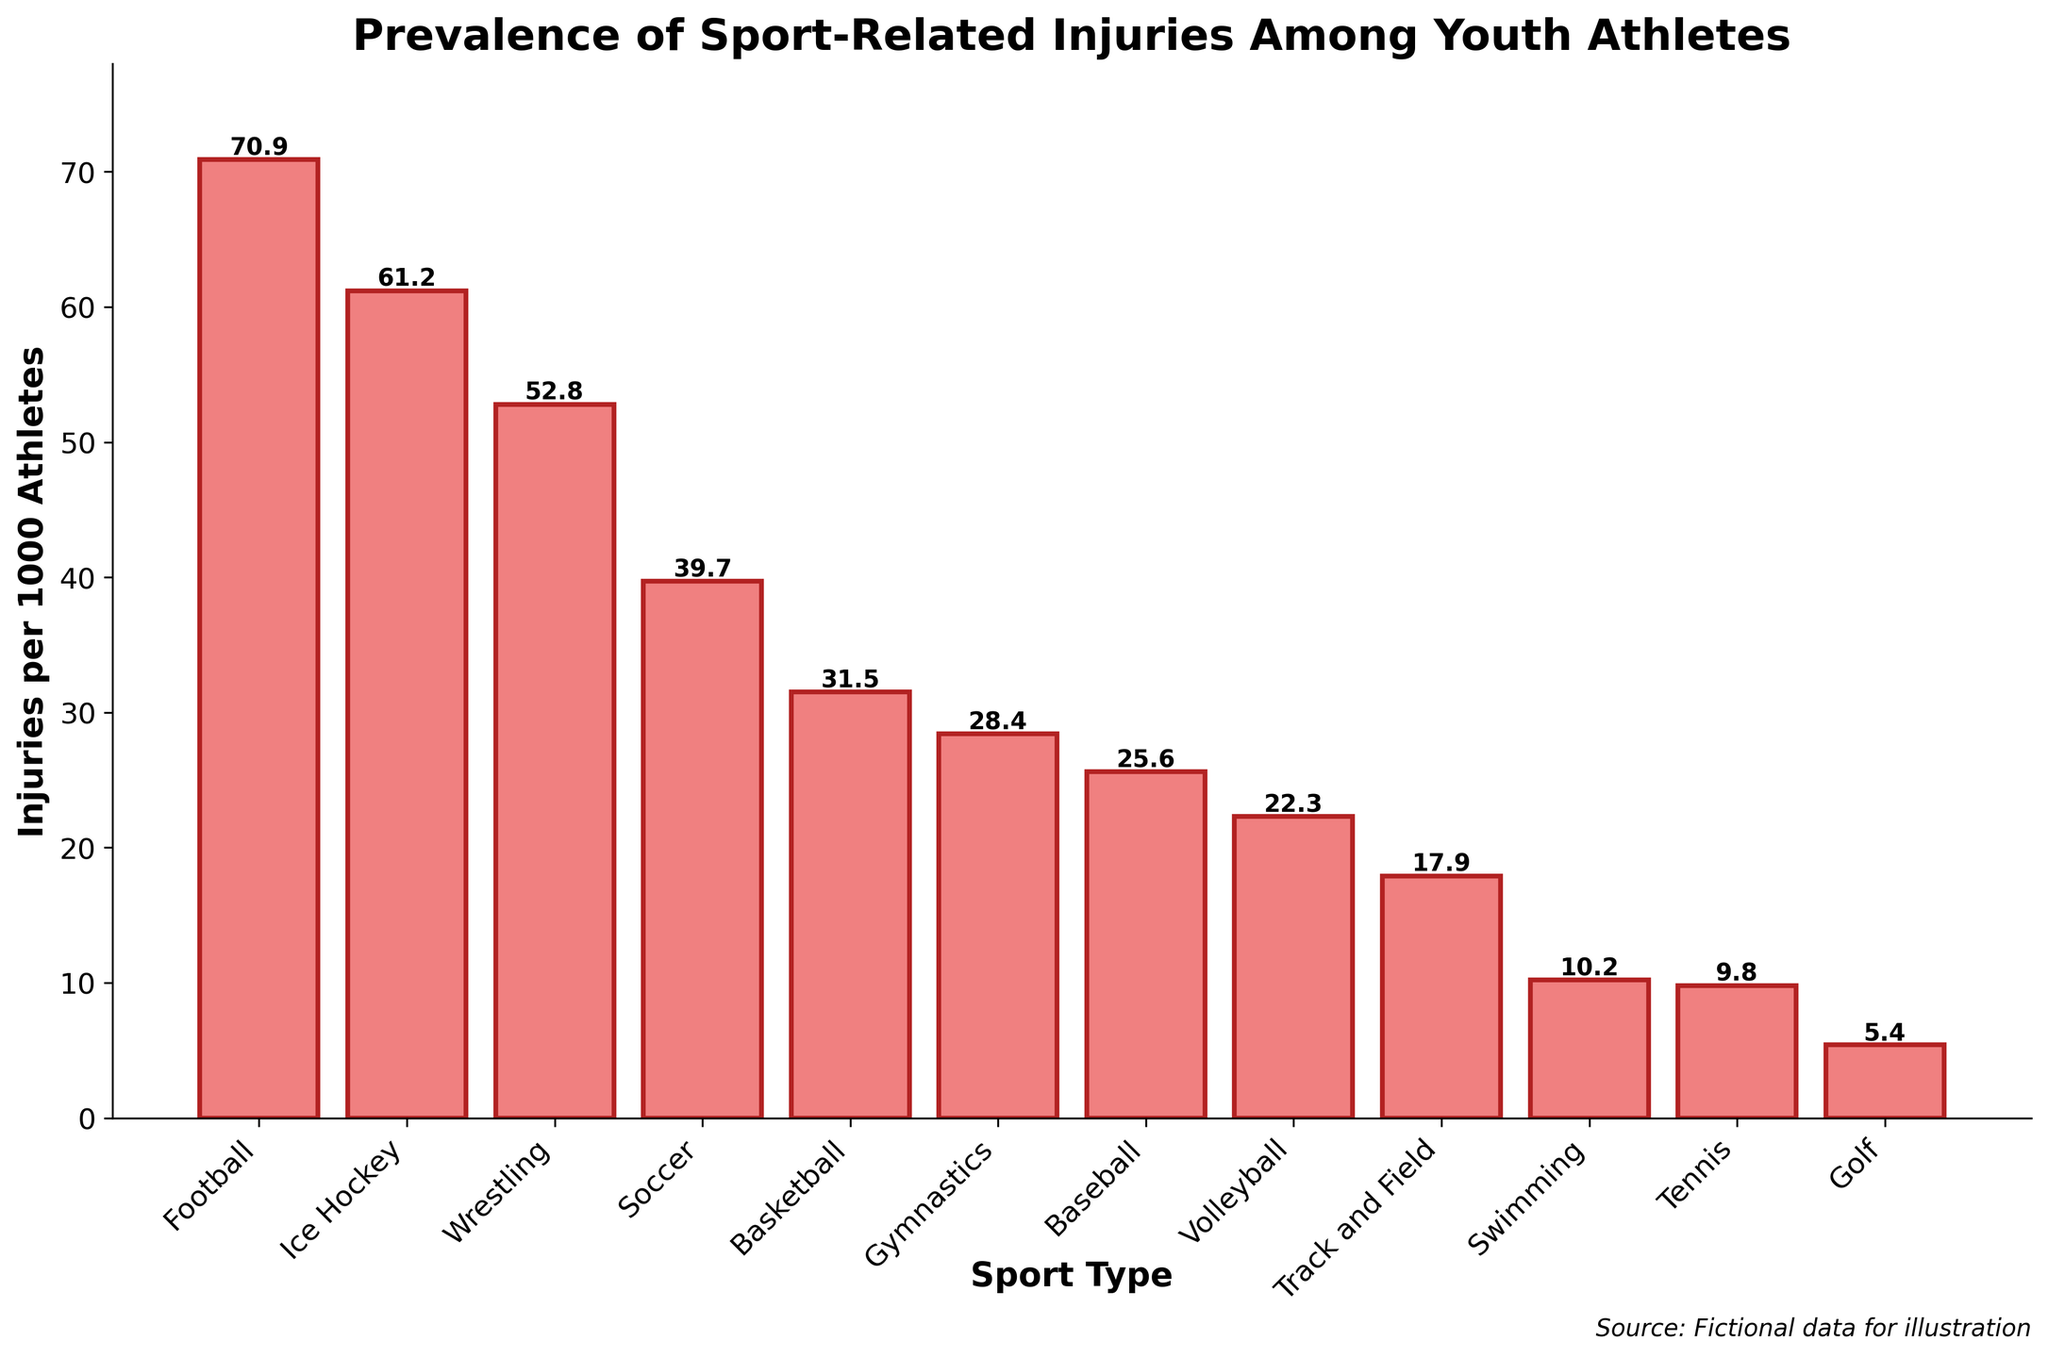Which sport has the highest number of injuries per 1000 athletes? By looking at the bar heights, it is clear that Football has the tallest bar, indicating it has the highest number of injuries per 1000 athletes.
Answer: Football How much higher is the injury rate in Football compared to Ice Hockey? Football has an injury rate of 70.9, while Ice Hockey has an injury rate of 61.2. The difference can be calculated as 70.9 - 61.2 = 9.7.
Answer: 9.7 Which sports have fewer than 20 injuries per 1000 athletes? The bars for Track and Field, Swimming, Tennis, and Golf are below the 20 mark on the y-axis.
Answer: Track and Field, Swimming, Tennis, Golf What is the sum of injury rates for Soccer and Basketball? The injury rate for Soccer is 39.7 and for Basketball is 31.5. Adding these together, we get 39.7 + 31.5 = 71.2.
Answer: 71.2 How does the injury rate in Volleyball compare to that in Gymnastics? Volleyball has an injury rate of 22.3, while Gymnastics has an injury rate of 28.4. Therefore, Volleyball has a lower injury rate compared to Gymnastics.
Answer: Lower Which sport has around half the injury rate of Football? Football has an injury rate of 70.9. Half of 70.9 is approximately 35.45. The closest sport to this value is Soccer, with an injury rate of 39.7.
Answer: Soccer Arrange the sports with injury rates over 50 in descending order. The sports with injury rates over 50 are Football (70.9), Ice Hockey (61.2), and Wrestling (52.8). Ordered from highest to lowest: Football, Ice Hockey, Wrestling.
Answer: Football, Ice Hockey, Wrestling What is the average injury rate of the sports with the lowest three injury rates? The sports with the lowest three injury rates are Golf (5.4), Tennis (9.8), and Swimming (10.2). The average is calculated as (5.4 + 9.8 + 10.2) / 3 = 8.5.
Answer: 8.5 